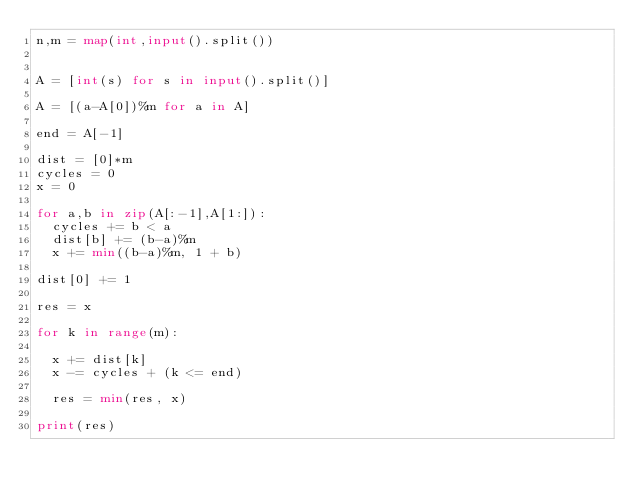Convert code to text. <code><loc_0><loc_0><loc_500><loc_500><_Python_>n,m = map(int,input().split())


A = [int(s) for s in input().split()]

A = [(a-A[0])%m for a in A]

end = A[-1]

dist = [0]*m
cycles = 0
x = 0

for a,b in zip(A[:-1],A[1:]):
  cycles += b < a
  dist[b] += (b-a)%m
  x += min((b-a)%m, 1 + b)

dist[0] += 1

res = x

for k in range(m):

  x += dist[k]
  x -= cycles + (k <= end)

  res = min(res, x)

print(res)</code> 